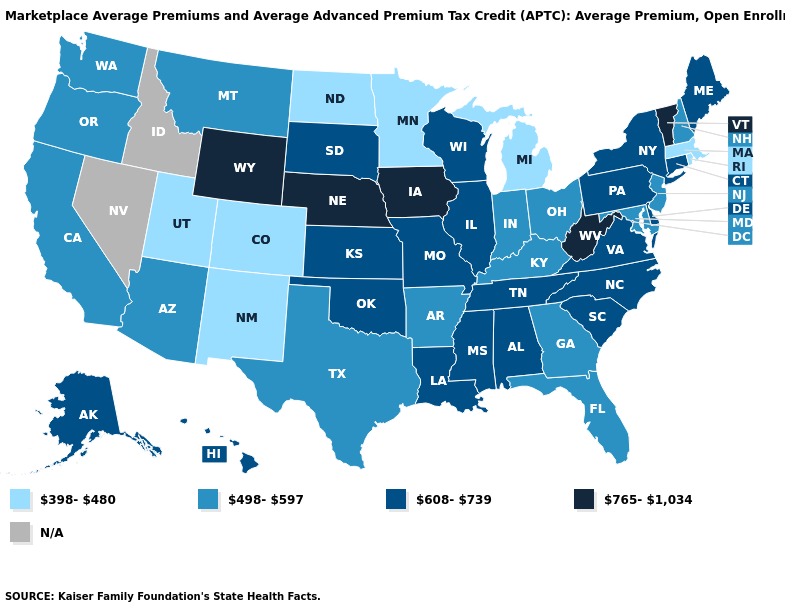Name the states that have a value in the range 498-597?
Keep it brief. Arizona, Arkansas, California, Florida, Georgia, Indiana, Kentucky, Maryland, Montana, New Hampshire, New Jersey, Ohio, Oregon, Texas, Washington. What is the value of Minnesota?
Answer briefly. 398-480. Name the states that have a value in the range N/A?
Keep it brief. Idaho, Nevada. Does the map have missing data?
Be succinct. Yes. Name the states that have a value in the range 398-480?
Be succinct. Colorado, Massachusetts, Michigan, Minnesota, New Mexico, North Dakota, Rhode Island, Utah. Does the map have missing data?
Keep it brief. Yes. What is the value of Iowa?
Short answer required. 765-1,034. Name the states that have a value in the range 498-597?
Short answer required. Arizona, Arkansas, California, Florida, Georgia, Indiana, Kentucky, Maryland, Montana, New Hampshire, New Jersey, Ohio, Oregon, Texas, Washington. Name the states that have a value in the range N/A?
Give a very brief answer. Idaho, Nevada. What is the value of Kentucky?
Be succinct. 498-597. Which states have the highest value in the USA?
Keep it brief. Iowa, Nebraska, Vermont, West Virginia, Wyoming. Name the states that have a value in the range 765-1,034?
Concise answer only. Iowa, Nebraska, Vermont, West Virginia, Wyoming. What is the value of Hawaii?
Be succinct. 608-739. Which states have the highest value in the USA?
Keep it brief. Iowa, Nebraska, Vermont, West Virginia, Wyoming. 